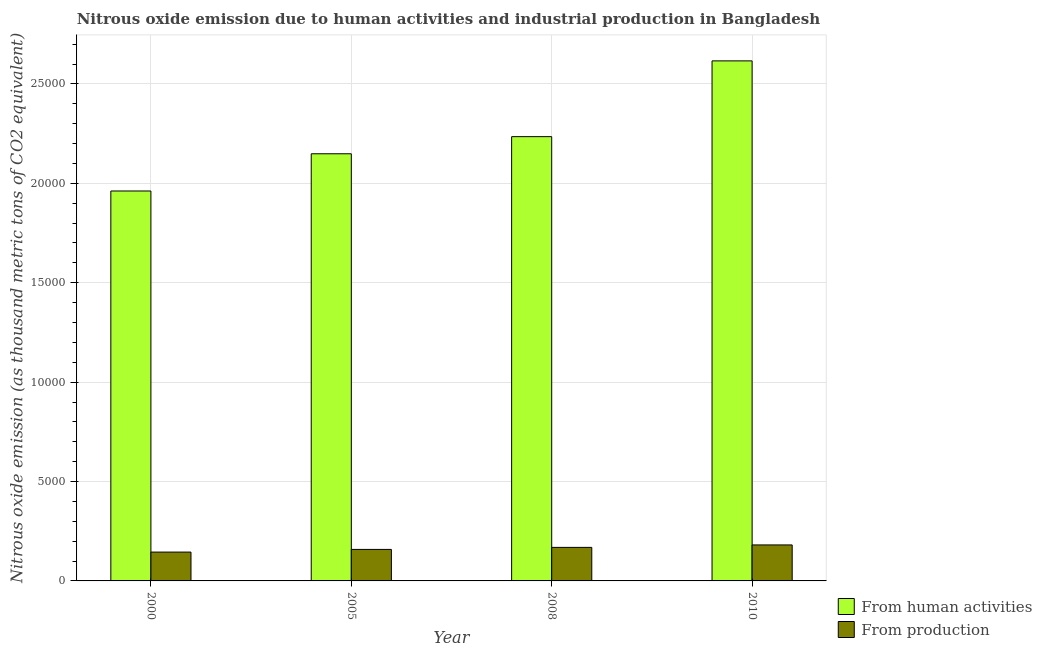How many different coloured bars are there?
Offer a terse response. 2. How many groups of bars are there?
Your response must be concise. 4. How many bars are there on the 1st tick from the left?
Ensure brevity in your answer.  2. In how many cases, is the number of bars for a given year not equal to the number of legend labels?
Provide a succinct answer. 0. What is the amount of emissions from human activities in 2010?
Provide a succinct answer. 2.62e+04. Across all years, what is the maximum amount of emissions generated from industries?
Offer a very short reply. 1810.8. Across all years, what is the minimum amount of emissions from human activities?
Provide a short and direct response. 1.96e+04. In which year was the amount of emissions from human activities maximum?
Offer a terse response. 2010. What is the total amount of emissions generated from industries in the graph?
Keep it short and to the point. 6532.6. What is the difference between the amount of emissions from human activities in 2000 and that in 2005?
Ensure brevity in your answer.  -1872.5. What is the difference between the amount of emissions from human activities in 2005 and the amount of emissions generated from industries in 2010?
Ensure brevity in your answer.  -4672.9. What is the average amount of emissions generated from industries per year?
Your response must be concise. 1633.15. In the year 2008, what is the difference between the amount of emissions from human activities and amount of emissions generated from industries?
Provide a succinct answer. 0. What is the ratio of the amount of emissions from human activities in 2000 to that in 2010?
Make the answer very short. 0.75. What is the difference between the highest and the second highest amount of emissions generated from industries?
Your response must be concise. 123.9. What is the difference between the highest and the lowest amount of emissions from human activities?
Provide a short and direct response. 6545.4. Is the sum of the amount of emissions from human activities in 2005 and 2010 greater than the maximum amount of emissions generated from industries across all years?
Provide a succinct answer. Yes. What does the 1st bar from the left in 2008 represents?
Ensure brevity in your answer.  From human activities. What does the 1st bar from the right in 2010 represents?
Provide a succinct answer. From production. How many bars are there?
Keep it short and to the point. 8. How many years are there in the graph?
Your response must be concise. 4. Does the graph contain any zero values?
Offer a terse response. No. Where does the legend appear in the graph?
Provide a short and direct response. Bottom right. How many legend labels are there?
Offer a very short reply. 2. What is the title of the graph?
Give a very brief answer. Nitrous oxide emission due to human activities and industrial production in Bangladesh. Does "Investment in Transport" appear as one of the legend labels in the graph?
Your answer should be compact. No. What is the label or title of the Y-axis?
Your response must be concise. Nitrous oxide emission (as thousand metric tons of CO2 equivalent). What is the Nitrous oxide emission (as thousand metric tons of CO2 equivalent) of From human activities in 2000?
Your response must be concise. 1.96e+04. What is the Nitrous oxide emission (as thousand metric tons of CO2 equivalent) of From production in 2000?
Your answer should be compact. 1450.3. What is the Nitrous oxide emission (as thousand metric tons of CO2 equivalent) in From human activities in 2005?
Keep it short and to the point. 2.15e+04. What is the Nitrous oxide emission (as thousand metric tons of CO2 equivalent) in From production in 2005?
Your answer should be compact. 1584.6. What is the Nitrous oxide emission (as thousand metric tons of CO2 equivalent) in From human activities in 2008?
Your answer should be compact. 2.23e+04. What is the Nitrous oxide emission (as thousand metric tons of CO2 equivalent) in From production in 2008?
Offer a terse response. 1686.9. What is the Nitrous oxide emission (as thousand metric tons of CO2 equivalent) of From human activities in 2010?
Ensure brevity in your answer.  2.62e+04. What is the Nitrous oxide emission (as thousand metric tons of CO2 equivalent) in From production in 2010?
Give a very brief answer. 1810.8. Across all years, what is the maximum Nitrous oxide emission (as thousand metric tons of CO2 equivalent) in From human activities?
Your answer should be very brief. 2.62e+04. Across all years, what is the maximum Nitrous oxide emission (as thousand metric tons of CO2 equivalent) of From production?
Offer a terse response. 1810.8. Across all years, what is the minimum Nitrous oxide emission (as thousand metric tons of CO2 equivalent) of From human activities?
Make the answer very short. 1.96e+04. Across all years, what is the minimum Nitrous oxide emission (as thousand metric tons of CO2 equivalent) of From production?
Make the answer very short. 1450.3. What is the total Nitrous oxide emission (as thousand metric tons of CO2 equivalent) in From human activities in the graph?
Offer a terse response. 8.96e+04. What is the total Nitrous oxide emission (as thousand metric tons of CO2 equivalent) of From production in the graph?
Keep it short and to the point. 6532.6. What is the difference between the Nitrous oxide emission (as thousand metric tons of CO2 equivalent) of From human activities in 2000 and that in 2005?
Your answer should be very brief. -1872.5. What is the difference between the Nitrous oxide emission (as thousand metric tons of CO2 equivalent) in From production in 2000 and that in 2005?
Provide a succinct answer. -134.3. What is the difference between the Nitrous oxide emission (as thousand metric tons of CO2 equivalent) of From human activities in 2000 and that in 2008?
Ensure brevity in your answer.  -2734.2. What is the difference between the Nitrous oxide emission (as thousand metric tons of CO2 equivalent) in From production in 2000 and that in 2008?
Make the answer very short. -236.6. What is the difference between the Nitrous oxide emission (as thousand metric tons of CO2 equivalent) in From human activities in 2000 and that in 2010?
Your response must be concise. -6545.4. What is the difference between the Nitrous oxide emission (as thousand metric tons of CO2 equivalent) in From production in 2000 and that in 2010?
Give a very brief answer. -360.5. What is the difference between the Nitrous oxide emission (as thousand metric tons of CO2 equivalent) in From human activities in 2005 and that in 2008?
Give a very brief answer. -861.7. What is the difference between the Nitrous oxide emission (as thousand metric tons of CO2 equivalent) of From production in 2005 and that in 2008?
Your response must be concise. -102.3. What is the difference between the Nitrous oxide emission (as thousand metric tons of CO2 equivalent) in From human activities in 2005 and that in 2010?
Offer a very short reply. -4672.9. What is the difference between the Nitrous oxide emission (as thousand metric tons of CO2 equivalent) in From production in 2005 and that in 2010?
Keep it short and to the point. -226.2. What is the difference between the Nitrous oxide emission (as thousand metric tons of CO2 equivalent) of From human activities in 2008 and that in 2010?
Offer a terse response. -3811.2. What is the difference between the Nitrous oxide emission (as thousand metric tons of CO2 equivalent) in From production in 2008 and that in 2010?
Give a very brief answer. -123.9. What is the difference between the Nitrous oxide emission (as thousand metric tons of CO2 equivalent) in From human activities in 2000 and the Nitrous oxide emission (as thousand metric tons of CO2 equivalent) in From production in 2005?
Ensure brevity in your answer.  1.80e+04. What is the difference between the Nitrous oxide emission (as thousand metric tons of CO2 equivalent) of From human activities in 2000 and the Nitrous oxide emission (as thousand metric tons of CO2 equivalent) of From production in 2008?
Give a very brief answer. 1.79e+04. What is the difference between the Nitrous oxide emission (as thousand metric tons of CO2 equivalent) of From human activities in 2000 and the Nitrous oxide emission (as thousand metric tons of CO2 equivalent) of From production in 2010?
Keep it short and to the point. 1.78e+04. What is the difference between the Nitrous oxide emission (as thousand metric tons of CO2 equivalent) of From human activities in 2005 and the Nitrous oxide emission (as thousand metric tons of CO2 equivalent) of From production in 2008?
Offer a very short reply. 1.98e+04. What is the difference between the Nitrous oxide emission (as thousand metric tons of CO2 equivalent) in From human activities in 2005 and the Nitrous oxide emission (as thousand metric tons of CO2 equivalent) in From production in 2010?
Provide a short and direct response. 1.97e+04. What is the difference between the Nitrous oxide emission (as thousand metric tons of CO2 equivalent) in From human activities in 2008 and the Nitrous oxide emission (as thousand metric tons of CO2 equivalent) in From production in 2010?
Provide a short and direct response. 2.05e+04. What is the average Nitrous oxide emission (as thousand metric tons of CO2 equivalent) in From human activities per year?
Ensure brevity in your answer.  2.24e+04. What is the average Nitrous oxide emission (as thousand metric tons of CO2 equivalent) of From production per year?
Keep it short and to the point. 1633.15. In the year 2000, what is the difference between the Nitrous oxide emission (as thousand metric tons of CO2 equivalent) of From human activities and Nitrous oxide emission (as thousand metric tons of CO2 equivalent) of From production?
Give a very brief answer. 1.82e+04. In the year 2005, what is the difference between the Nitrous oxide emission (as thousand metric tons of CO2 equivalent) in From human activities and Nitrous oxide emission (as thousand metric tons of CO2 equivalent) in From production?
Your answer should be compact. 1.99e+04. In the year 2008, what is the difference between the Nitrous oxide emission (as thousand metric tons of CO2 equivalent) of From human activities and Nitrous oxide emission (as thousand metric tons of CO2 equivalent) of From production?
Offer a terse response. 2.07e+04. In the year 2010, what is the difference between the Nitrous oxide emission (as thousand metric tons of CO2 equivalent) of From human activities and Nitrous oxide emission (as thousand metric tons of CO2 equivalent) of From production?
Offer a very short reply. 2.43e+04. What is the ratio of the Nitrous oxide emission (as thousand metric tons of CO2 equivalent) in From human activities in 2000 to that in 2005?
Keep it short and to the point. 0.91. What is the ratio of the Nitrous oxide emission (as thousand metric tons of CO2 equivalent) of From production in 2000 to that in 2005?
Ensure brevity in your answer.  0.92. What is the ratio of the Nitrous oxide emission (as thousand metric tons of CO2 equivalent) of From human activities in 2000 to that in 2008?
Offer a very short reply. 0.88. What is the ratio of the Nitrous oxide emission (as thousand metric tons of CO2 equivalent) in From production in 2000 to that in 2008?
Provide a short and direct response. 0.86. What is the ratio of the Nitrous oxide emission (as thousand metric tons of CO2 equivalent) of From human activities in 2000 to that in 2010?
Your response must be concise. 0.75. What is the ratio of the Nitrous oxide emission (as thousand metric tons of CO2 equivalent) of From production in 2000 to that in 2010?
Keep it short and to the point. 0.8. What is the ratio of the Nitrous oxide emission (as thousand metric tons of CO2 equivalent) of From human activities in 2005 to that in 2008?
Your answer should be very brief. 0.96. What is the ratio of the Nitrous oxide emission (as thousand metric tons of CO2 equivalent) of From production in 2005 to that in 2008?
Offer a terse response. 0.94. What is the ratio of the Nitrous oxide emission (as thousand metric tons of CO2 equivalent) of From human activities in 2005 to that in 2010?
Provide a short and direct response. 0.82. What is the ratio of the Nitrous oxide emission (as thousand metric tons of CO2 equivalent) in From production in 2005 to that in 2010?
Your answer should be very brief. 0.88. What is the ratio of the Nitrous oxide emission (as thousand metric tons of CO2 equivalent) of From human activities in 2008 to that in 2010?
Your answer should be compact. 0.85. What is the ratio of the Nitrous oxide emission (as thousand metric tons of CO2 equivalent) in From production in 2008 to that in 2010?
Offer a terse response. 0.93. What is the difference between the highest and the second highest Nitrous oxide emission (as thousand metric tons of CO2 equivalent) in From human activities?
Provide a succinct answer. 3811.2. What is the difference between the highest and the second highest Nitrous oxide emission (as thousand metric tons of CO2 equivalent) in From production?
Ensure brevity in your answer.  123.9. What is the difference between the highest and the lowest Nitrous oxide emission (as thousand metric tons of CO2 equivalent) of From human activities?
Make the answer very short. 6545.4. What is the difference between the highest and the lowest Nitrous oxide emission (as thousand metric tons of CO2 equivalent) of From production?
Offer a terse response. 360.5. 